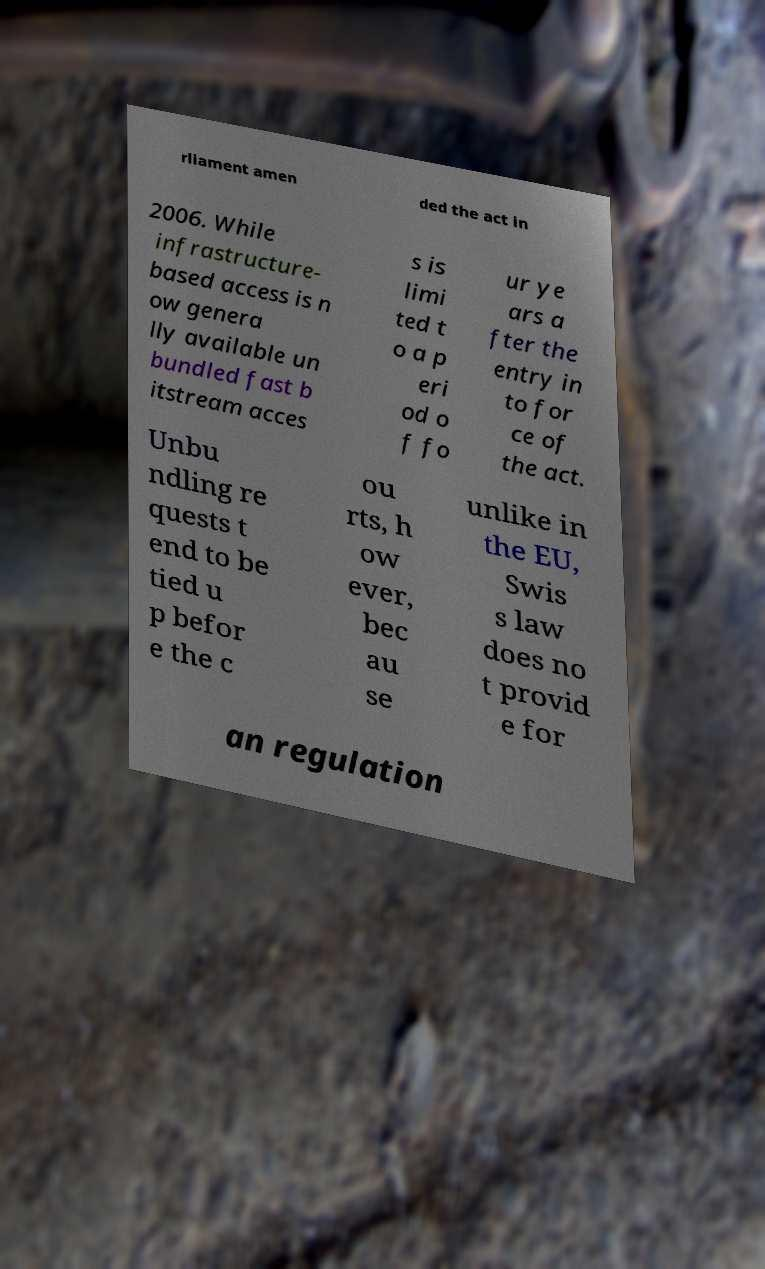Please read and relay the text visible in this image. What does it say? rliament amen ded the act in 2006. While infrastructure- based access is n ow genera lly available un bundled fast b itstream acces s is limi ted t o a p eri od o f fo ur ye ars a fter the entry in to for ce of the act. Unbu ndling re quests t end to be tied u p befor e the c ou rts, h ow ever, bec au se unlike in the EU, Swis s law does no t provid e for an regulation 